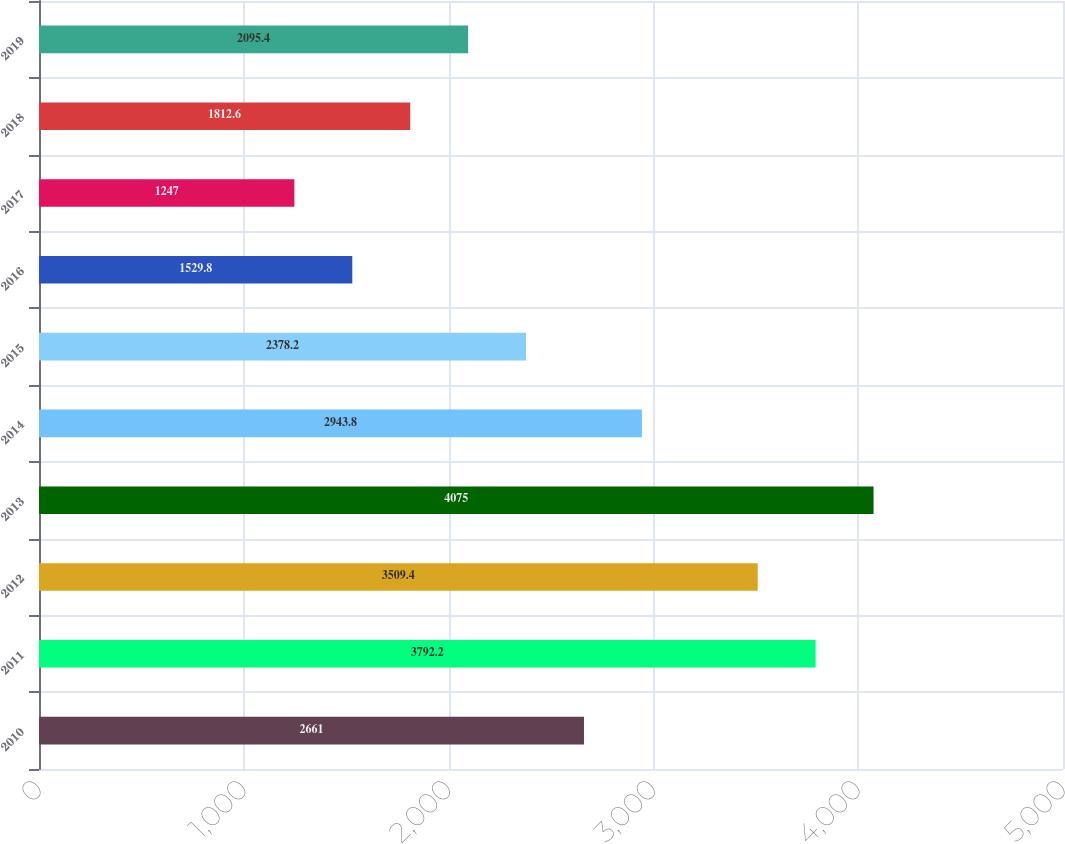Convert chart to OTSL. <chart><loc_0><loc_0><loc_500><loc_500><bar_chart><fcel>2010<fcel>2011<fcel>2012<fcel>2013<fcel>2014<fcel>2015<fcel>2016<fcel>2017<fcel>2018<fcel>2019<nl><fcel>2661<fcel>3792.2<fcel>3509.4<fcel>4075<fcel>2943.8<fcel>2378.2<fcel>1529.8<fcel>1247<fcel>1812.6<fcel>2095.4<nl></chart> 